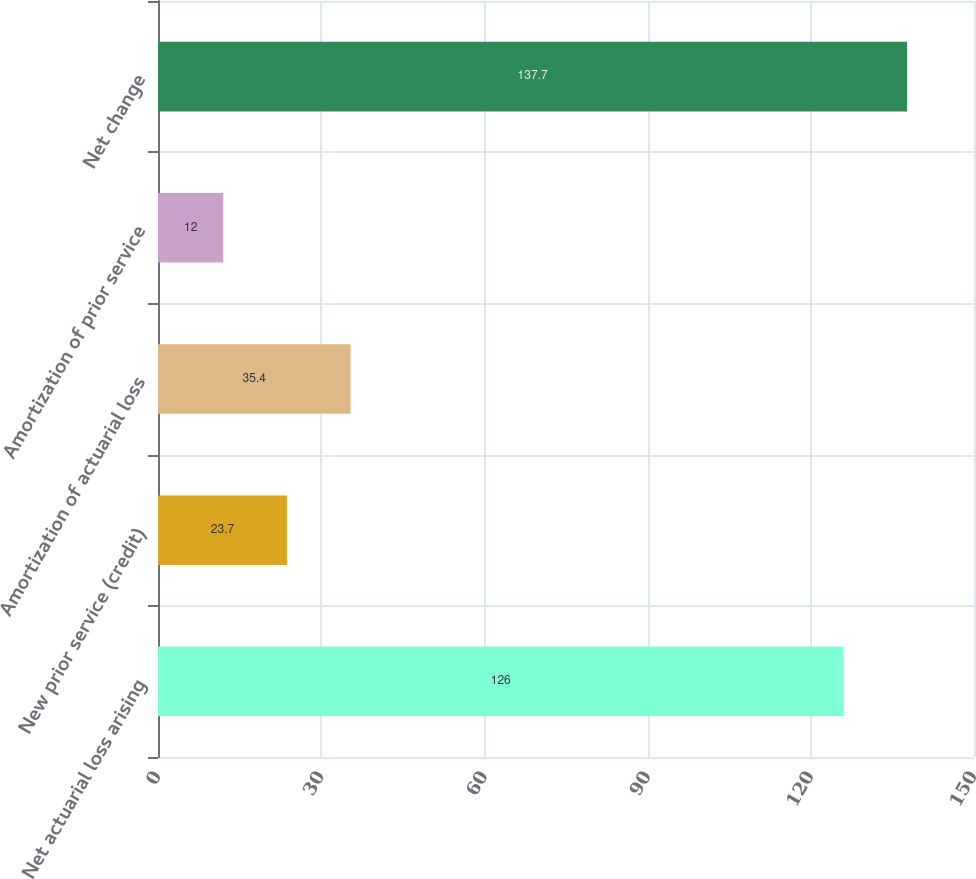Convert chart. <chart><loc_0><loc_0><loc_500><loc_500><bar_chart><fcel>Net actuarial loss arising<fcel>New prior service (credit)<fcel>Amortization of actuarial loss<fcel>Amortization of prior service<fcel>Net change<nl><fcel>126<fcel>23.7<fcel>35.4<fcel>12<fcel>137.7<nl></chart> 